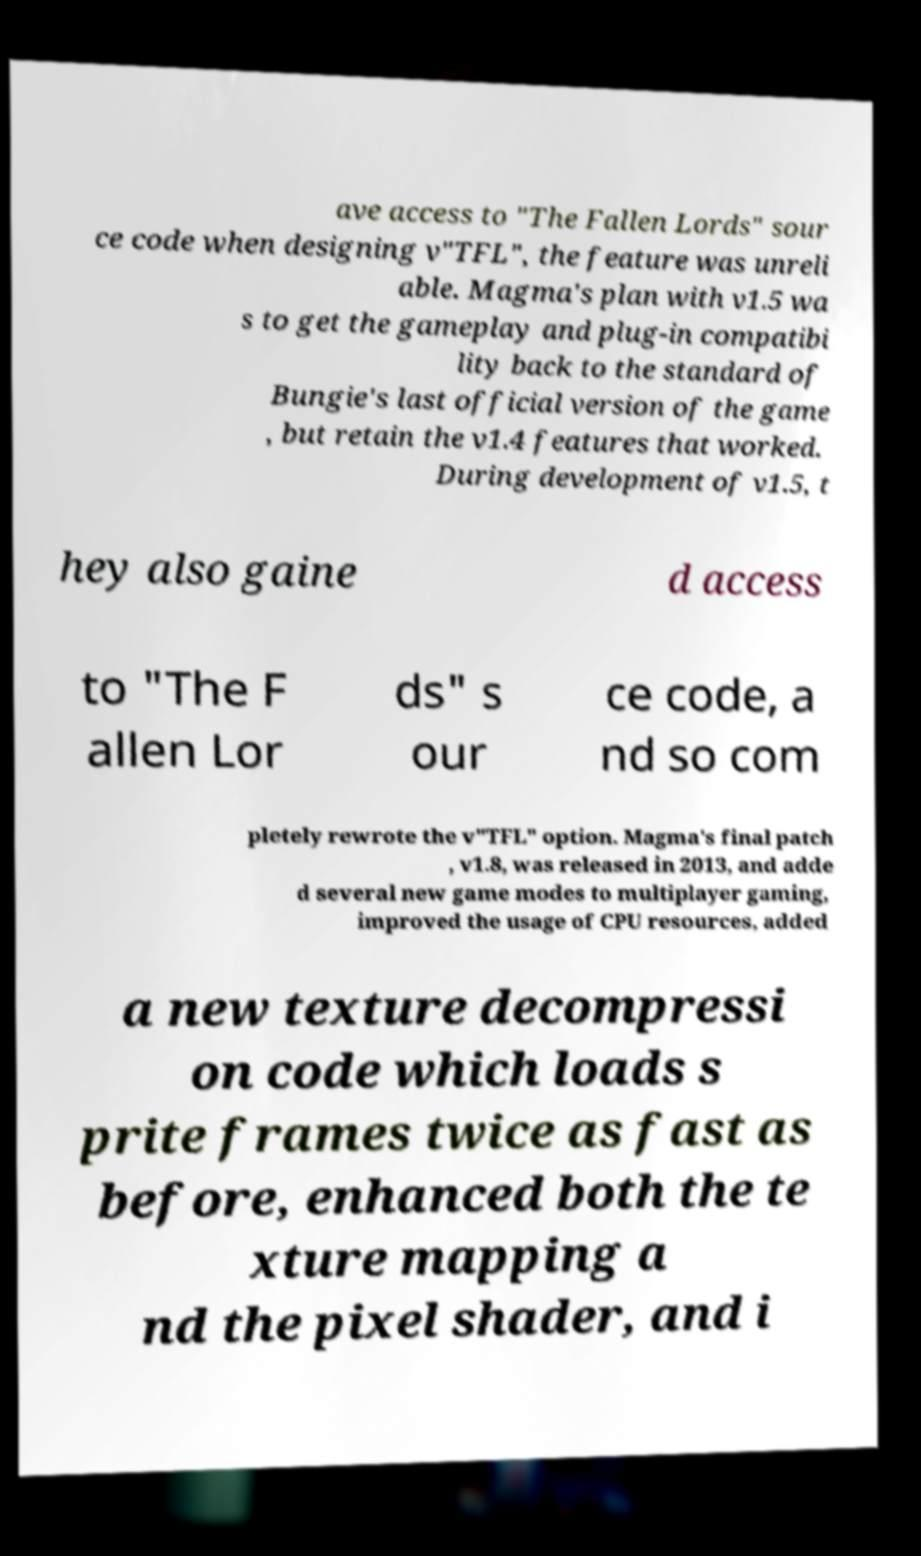Please read and relay the text visible in this image. What does it say? ave access to "The Fallen Lords" sour ce code when designing v"TFL", the feature was unreli able. Magma's plan with v1.5 wa s to get the gameplay and plug-in compatibi lity back to the standard of Bungie's last official version of the game , but retain the v1.4 features that worked. During development of v1.5, t hey also gaine d access to "The F allen Lor ds" s our ce code, a nd so com pletely rewrote the v"TFL" option. Magma's final patch , v1.8, was released in 2013, and adde d several new game modes to multiplayer gaming, improved the usage of CPU resources, added a new texture decompressi on code which loads s prite frames twice as fast as before, enhanced both the te xture mapping a nd the pixel shader, and i 